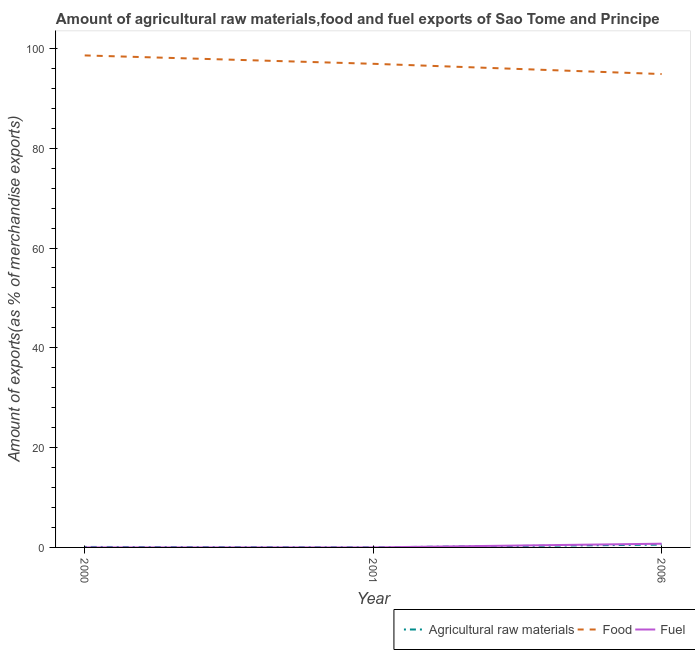Does the line corresponding to percentage of fuel exports intersect with the line corresponding to percentage of food exports?
Your answer should be compact. No. What is the percentage of raw materials exports in 2006?
Provide a short and direct response. 0.56. Across all years, what is the maximum percentage of food exports?
Your answer should be compact. 98.6. Across all years, what is the minimum percentage of fuel exports?
Your answer should be very brief. 0. What is the total percentage of food exports in the graph?
Offer a terse response. 290.39. What is the difference between the percentage of food exports in 2000 and that in 2006?
Provide a succinct answer. 3.73. What is the difference between the percentage of raw materials exports in 2006 and the percentage of fuel exports in 2001?
Provide a succinct answer. 0.56. What is the average percentage of raw materials exports per year?
Make the answer very short. 0.23. In the year 2000, what is the difference between the percentage of food exports and percentage of raw materials exports?
Your answer should be very brief. 98.5. What is the ratio of the percentage of food exports in 2001 to that in 2006?
Ensure brevity in your answer.  1.02. Is the percentage of food exports in 2000 less than that in 2006?
Provide a succinct answer. No. Is the difference between the percentage of raw materials exports in 2000 and 2001 greater than the difference between the percentage of food exports in 2000 and 2001?
Give a very brief answer. No. What is the difference between the highest and the second highest percentage of food exports?
Your answer should be compact. 1.68. What is the difference between the highest and the lowest percentage of raw materials exports?
Provide a short and direct response. 0.54. Does the percentage of food exports monotonically increase over the years?
Provide a succinct answer. No. Is the percentage of food exports strictly less than the percentage of fuel exports over the years?
Offer a terse response. No. How many lines are there?
Provide a succinct answer. 3. What is the difference between two consecutive major ticks on the Y-axis?
Your response must be concise. 20. Are the values on the major ticks of Y-axis written in scientific E-notation?
Offer a terse response. No. Does the graph contain any zero values?
Offer a terse response. No. Where does the legend appear in the graph?
Provide a succinct answer. Bottom right. How many legend labels are there?
Your answer should be compact. 3. What is the title of the graph?
Make the answer very short. Amount of agricultural raw materials,food and fuel exports of Sao Tome and Principe. What is the label or title of the Y-axis?
Offer a very short reply. Amount of exports(as % of merchandise exports). What is the Amount of exports(as % of merchandise exports) in Agricultural raw materials in 2000?
Provide a succinct answer. 0.1. What is the Amount of exports(as % of merchandise exports) of Food in 2000?
Give a very brief answer. 98.6. What is the Amount of exports(as % of merchandise exports) of Fuel in 2000?
Provide a succinct answer. 0. What is the Amount of exports(as % of merchandise exports) of Agricultural raw materials in 2001?
Keep it short and to the point. 0.02. What is the Amount of exports(as % of merchandise exports) of Food in 2001?
Give a very brief answer. 96.92. What is the Amount of exports(as % of merchandise exports) in Fuel in 2001?
Your response must be concise. 0.01. What is the Amount of exports(as % of merchandise exports) of Agricultural raw materials in 2006?
Give a very brief answer. 0.56. What is the Amount of exports(as % of merchandise exports) in Food in 2006?
Your answer should be very brief. 94.87. What is the Amount of exports(as % of merchandise exports) in Fuel in 2006?
Your answer should be very brief. 0.75. Across all years, what is the maximum Amount of exports(as % of merchandise exports) of Agricultural raw materials?
Offer a terse response. 0.56. Across all years, what is the maximum Amount of exports(as % of merchandise exports) of Food?
Your answer should be compact. 98.6. Across all years, what is the maximum Amount of exports(as % of merchandise exports) of Fuel?
Provide a short and direct response. 0.75. Across all years, what is the minimum Amount of exports(as % of merchandise exports) in Agricultural raw materials?
Provide a short and direct response. 0.02. Across all years, what is the minimum Amount of exports(as % of merchandise exports) in Food?
Provide a succinct answer. 94.87. Across all years, what is the minimum Amount of exports(as % of merchandise exports) of Fuel?
Provide a short and direct response. 0. What is the total Amount of exports(as % of merchandise exports) of Agricultural raw materials in the graph?
Your answer should be very brief. 0.68. What is the total Amount of exports(as % of merchandise exports) of Food in the graph?
Offer a terse response. 290.39. What is the total Amount of exports(as % of merchandise exports) in Fuel in the graph?
Your response must be concise. 0.75. What is the difference between the Amount of exports(as % of merchandise exports) of Agricultural raw materials in 2000 and that in 2001?
Keep it short and to the point. 0.07. What is the difference between the Amount of exports(as % of merchandise exports) in Food in 2000 and that in 2001?
Ensure brevity in your answer.  1.68. What is the difference between the Amount of exports(as % of merchandise exports) in Fuel in 2000 and that in 2001?
Your response must be concise. -0.01. What is the difference between the Amount of exports(as % of merchandise exports) in Agricultural raw materials in 2000 and that in 2006?
Your answer should be very brief. -0.47. What is the difference between the Amount of exports(as % of merchandise exports) of Food in 2000 and that in 2006?
Your answer should be compact. 3.73. What is the difference between the Amount of exports(as % of merchandise exports) in Fuel in 2000 and that in 2006?
Provide a succinct answer. -0.75. What is the difference between the Amount of exports(as % of merchandise exports) of Agricultural raw materials in 2001 and that in 2006?
Provide a succinct answer. -0.54. What is the difference between the Amount of exports(as % of merchandise exports) of Food in 2001 and that in 2006?
Provide a short and direct response. 2.05. What is the difference between the Amount of exports(as % of merchandise exports) of Fuel in 2001 and that in 2006?
Give a very brief answer. -0.74. What is the difference between the Amount of exports(as % of merchandise exports) in Agricultural raw materials in 2000 and the Amount of exports(as % of merchandise exports) in Food in 2001?
Offer a very short reply. -96.82. What is the difference between the Amount of exports(as % of merchandise exports) in Agricultural raw materials in 2000 and the Amount of exports(as % of merchandise exports) in Fuel in 2001?
Keep it short and to the point. 0.09. What is the difference between the Amount of exports(as % of merchandise exports) of Food in 2000 and the Amount of exports(as % of merchandise exports) of Fuel in 2001?
Give a very brief answer. 98.59. What is the difference between the Amount of exports(as % of merchandise exports) in Agricultural raw materials in 2000 and the Amount of exports(as % of merchandise exports) in Food in 2006?
Give a very brief answer. -94.77. What is the difference between the Amount of exports(as % of merchandise exports) in Agricultural raw materials in 2000 and the Amount of exports(as % of merchandise exports) in Fuel in 2006?
Ensure brevity in your answer.  -0.65. What is the difference between the Amount of exports(as % of merchandise exports) in Food in 2000 and the Amount of exports(as % of merchandise exports) in Fuel in 2006?
Ensure brevity in your answer.  97.85. What is the difference between the Amount of exports(as % of merchandise exports) of Agricultural raw materials in 2001 and the Amount of exports(as % of merchandise exports) of Food in 2006?
Your response must be concise. -94.84. What is the difference between the Amount of exports(as % of merchandise exports) in Agricultural raw materials in 2001 and the Amount of exports(as % of merchandise exports) in Fuel in 2006?
Your answer should be compact. -0.72. What is the difference between the Amount of exports(as % of merchandise exports) in Food in 2001 and the Amount of exports(as % of merchandise exports) in Fuel in 2006?
Make the answer very short. 96.17. What is the average Amount of exports(as % of merchandise exports) of Agricultural raw materials per year?
Provide a short and direct response. 0.23. What is the average Amount of exports(as % of merchandise exports) of Food per year?
Your answer should be compact. 96.8. What is the average Amount of exports(as % of merchandise exports) of Fuel per year?
Your response must be concise. 0.25. In the year 2000, what is the difference between the Amount of exports(as % of merchandise exports) in Agricultural raw materials and Amount of exports(as % of merchandise exports) in Food?
Your answer should be very brief. -98.5. In the year 2000, what is the difference between the Amount of exports(as % of merchandise exports) of Agricultural raw materials and Amount of exports(as % of merchandise exports) of Fuel?
Ensure brevity in your answer.  0.1. In the year 2000, what is the difference between the Amount of exports(as % of merchandise exports) of Food and Amount of exports(as % of merchandise exports) of Fuel?
Keep it short and to the point. 98.6. In the year 2001, what is the difference between the Amount of exports(as % of merchandise exports) in Agricultural raw materials and Amount of exports(as % of merchandise exports) in Food?
Offer a very short reply. -96.9. In the year 2001, what is the difference between the Amount of exports(as % of merchandise exports) in Agricultural raw materials and Amount of exports(as % of merchandise exports) in Fuel?
Offer a very short reply. 0.02. In the year 2001, what is the difference between the Amount of exports(as % of merchandise exports) of Food and Amount of exports(as % of merchandise exports) of Fuel?
Your response must be concise. 96.92. In the year 2006, what is the difference between the Amount of exports(as % of merchandise exports) of Agricultural raw materials and Amount of exports(as % of merchandise exports) of Food?
Your answer should be very brief. -94.31. In the year 2006, what is the difference between the Amount of exports(as % of merchandise exports) in Agricultural raw materials and Amount of exports(as % of merchandise exports) in Fuel?
Your answer should be very brief. -0.18. In the year 2006, what is the difference between the Amount of exports(as % of merchandise exports) of Food and Amount of exports(as % of merchandise exports) of Fuel?
Keep it short and to the point. 94.12. What is the ratio of the Amount of exports(as % of merchandise exports) of Agricultural raw materials in 2000 to that in 2001?
Ensure brevity in your answer.  4.28. What is the ratio of the Amount of exports(as % of merchandise exports) in Food in 2000 to that in 2001?
Make the answer very short. 1.02. What is the ratio of the Amount of exports(as % of merchandise exports) in Fuel in 2000 to that in 2001?
Your answer should be compact. 0.02. What is the ratio of the Amount of exports(as % of merchandise exports) of Agricultural raw materials in 2000 to that in 2006?
Your response must be concise. 0.17. What is the ratio of the Amount of exports(as % of merchandise exports) of Food in 2000 to that in 2006?
Make the answer very short. 1.04. What is the ratio of the Amount of exports(as % of merchandise exports) in Agricultural raw materials in 2001 to that in 2006?
Keep it short and to the point. 0.04. What is the ratio of the Amount of exports(as % of merchandise exports) in Food in 2001 to that in 2006?
Your answer should be very brief. 1.02. What is the ratio of the Amount of exports(as % of merchandise exports) of Fuel in 2001 to that in 2006?
Offer a very short reply. 0.01. What is the difference between the highest and the second highest Amount of exports(as % of merchandise exports) of Agricultural raw materials?
Provide a short and direct response. 0.47. What is the difference between the highest and the second highest Amount of exports(as % of merchandise exports) in Food?
Provide a succinct answer. 1.68. What is the difference between the highest and the second highest Amount of exports(as % of merchandise exports) in Fuel?
Ensure brevity in your answer.  0.74. What is the difference between the highest and the lowest Amount of exports(as % of merchandise exports) of Agricultural raw materials?
Keep it short and to the point. 0.54. What is the difference between the highest and the lowest Amount of exports(as % of merchandise exports) of Food?
Provide a succinct answer. 3.73. What is the difference between the highest and the lowest Amount of exports(as % of merchandise exports) in Fuel?
Ensure brevity in your answer.  0.75. 